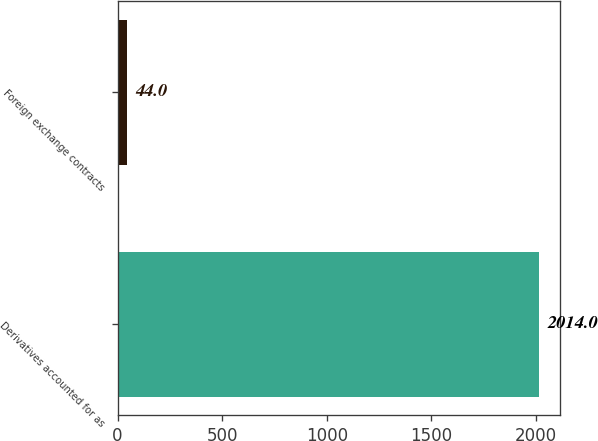<chart> <loc_0><loc_0><loc_500><loc_500><bar_chart><fcel>Derivatives accounted for as<fcel>Foreign exchange contracts<nl><fcel>2014<fcel>44<nl></chart> 